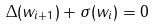Convert formula to latex. <formula><loc_0><loc_0><loc_500><loc_500>\Delta ( w _ { i + 1 } ) + \sigma ( w _ { i } ) = 0</formula> 